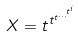<formula> <loc_0><loc_0><loc_500><loc_500>X = t ^ { t ^ { t ^ { \dots ^ { t ^ { i } } } } }</formula> 